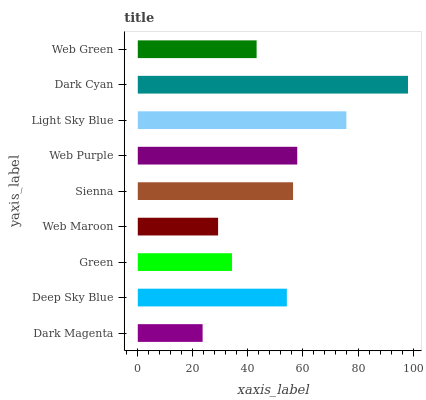Is Dark Magenta the minimum?
Answer yes or no. Yes. Is Dark Cyan the maximum?
Answer yes or no. Yes. Is Deep Sky Blue the minimum?
Answer yes or no. No. Is Deep Sky Blue the maximum?
Answer yes or no. No. Is Deep Sky Blue greater than Dark Magenta?
Answer yes or no. Yes. Is Dark Magenta less than Deep Sky Blue?
Answer yes or no. Yes. Is Dark Magenta greater than Deep Sky Blue?
Answer yes or no. No. Is Deep Sky Blue less than Dark Magenta?
Answer yes or no. No. Is Deep Sky Blue the high median?
Answer yes or no. Yes. Is Deep Sky Blue the low median?
Answer yes or no. Yes. Is Sienna the high median?
Answer yes or no. No. Is Web Maroon the low median?
Answer yes or no. No. 